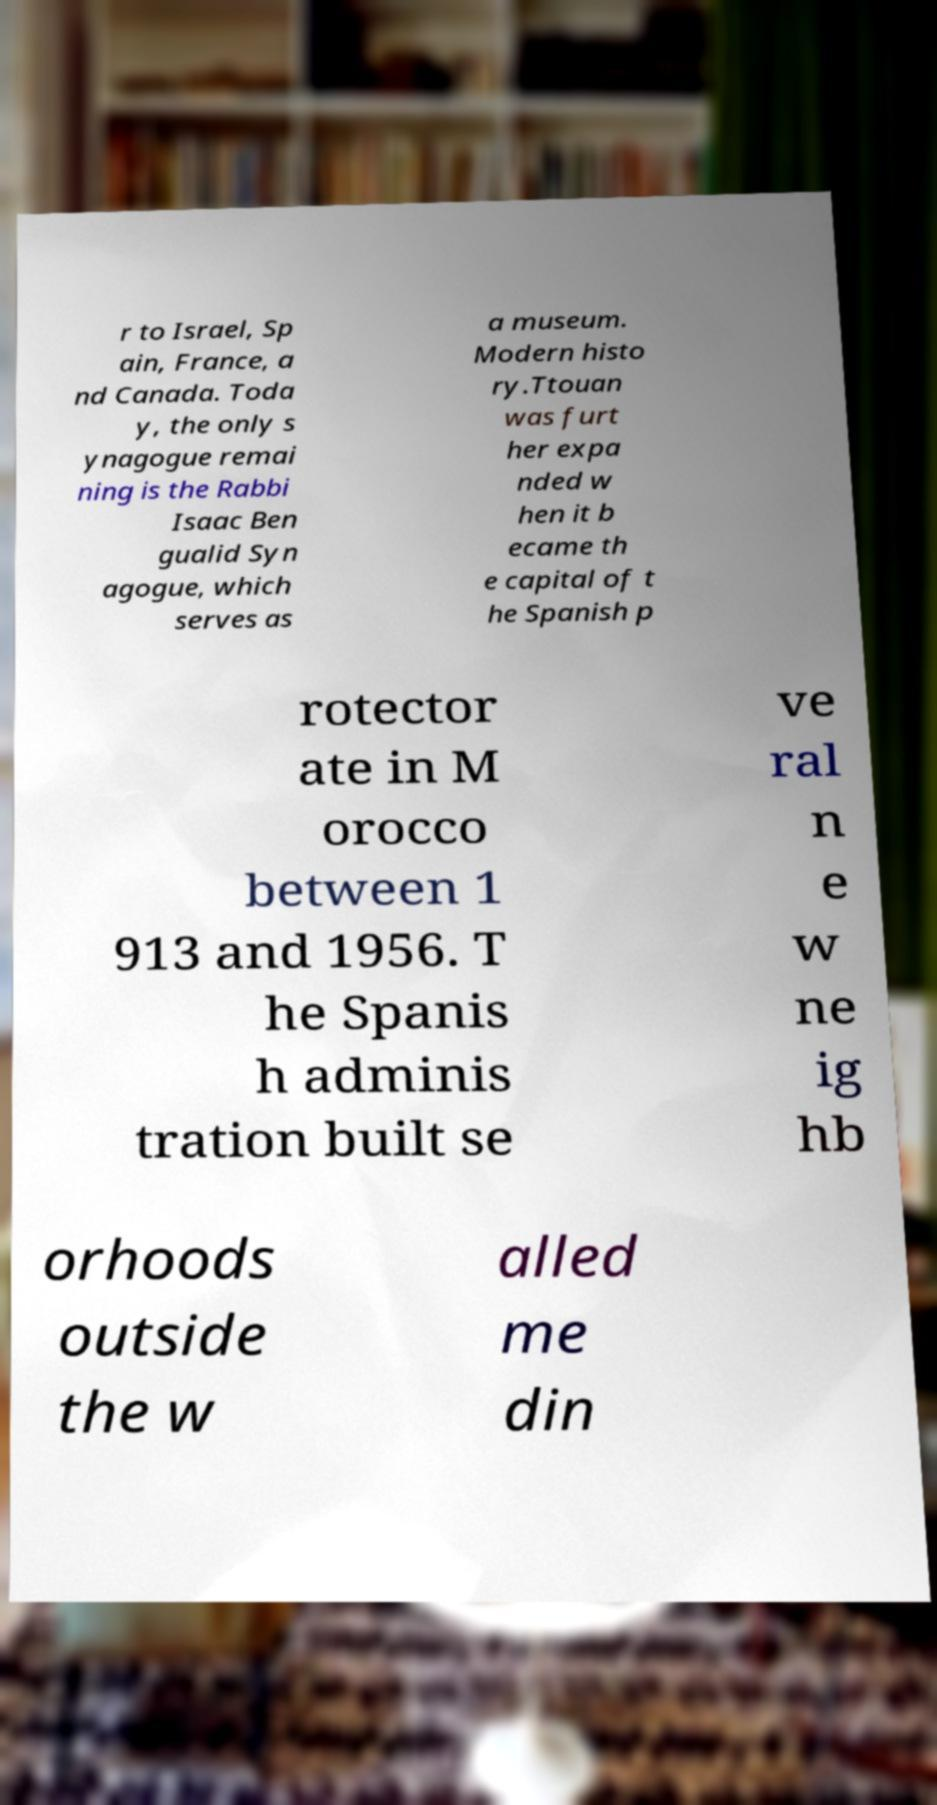Can you read and provide the text displayed in the image?This photo seems to have some interesting text. Can you extract and type it out for me? r to Israel, Sp ain, France, a nd Canada. Toda y, the only s ynagogue remai ning is the Rabbi Isaac Ben gualid Syn agogue, which serves as a museum. Modern histo ry.Ttouan was furt her expa nded w hen it b ecame th e capital of t he Spanish p rotector ate in M orocco between 1 913 and 1956. T he Spanis h adminis tration built se ve ral n e w ne ig hb orhoods outside the w alled me din 